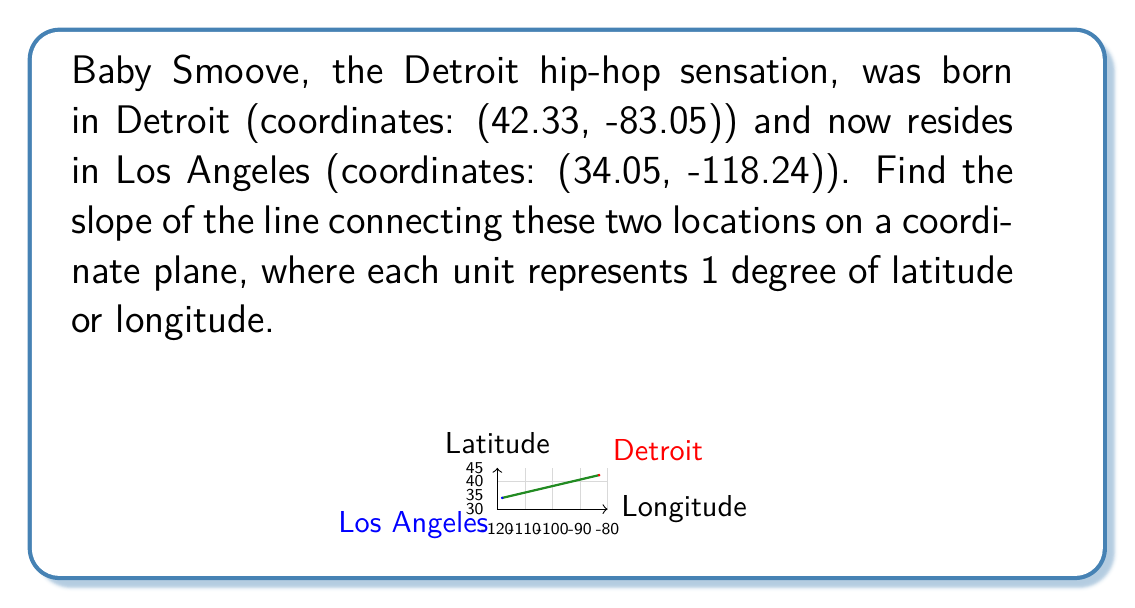Solve this math problem. To find the slope of the line connecting two points, we use the slope formula:

$$ m = \frac{y_2 - y_1}{x_2 - x_1} $$

Where $(x_1, y_1)$ is the first point and $(x_2, y_2)$ is the second point.

Let's assign our points:
Detroit (birth place): $(x_1, y_1) = (-83.05, 42.33)$
Los Angeles (current residence): $(x_2, y_2) = (-118.24, 34.05)$

Now, let's substitute these values into the slope formula:

$$ m = \frac{34.05 - 42.33}{-118.24 - (-83.05)} $$

Simplifying:

$$ m = \frac{-8.28}{-35.19} $$

Dividing:

$$ m \approx 0.2353 $$

This slope represents the change in latitude per unit change in longitude as Baby Smoove moved from Detroit to Los Angeles.
Answer: $0.2353$ 